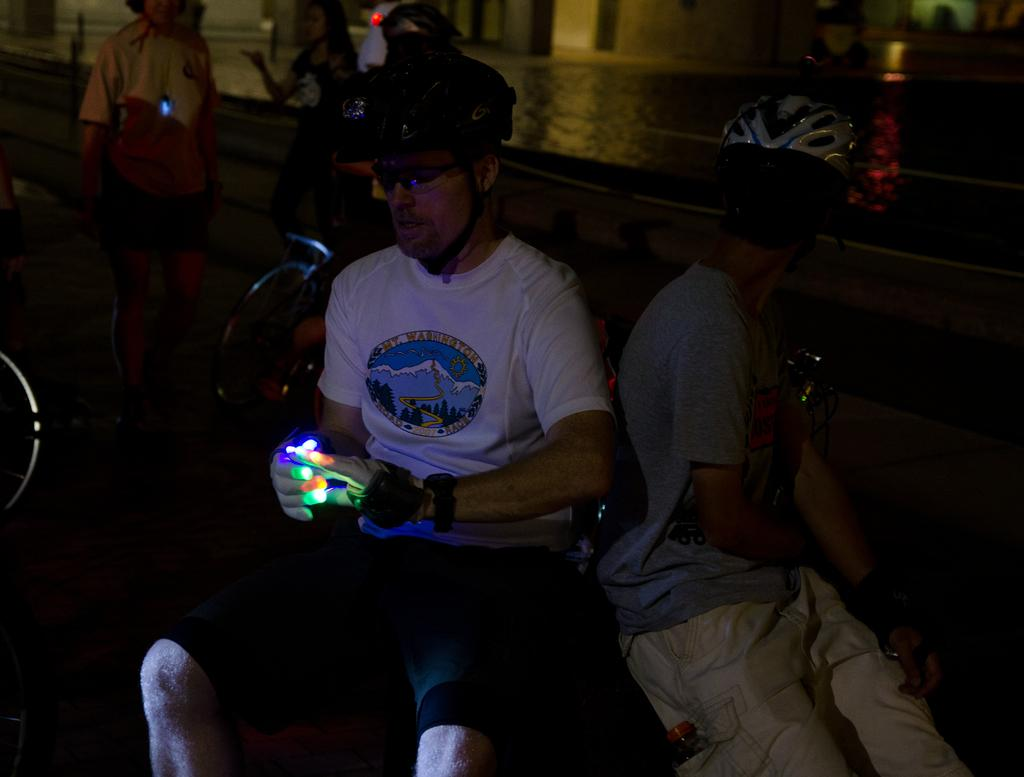What is the person in the front of the image doing? The person is sitting in the front of the image. What is the person holding in the image? The person is holding an object. What can be seen on the person's head in the image? The person is wearing a black color helmet. What can be seen in the background of the image? There are persons in the background of the image, and there is water visible in the background. What type of riddle is the person trying to solve in the image? There is no riddle present in the image; the person is simply sitting and holding an object. What is the selection process for the trail in the image? There is no trail or selection process mentioned in the image; it only shows a person sitting, wearing a helmet, and holding an object, along with persons and water in the background. 